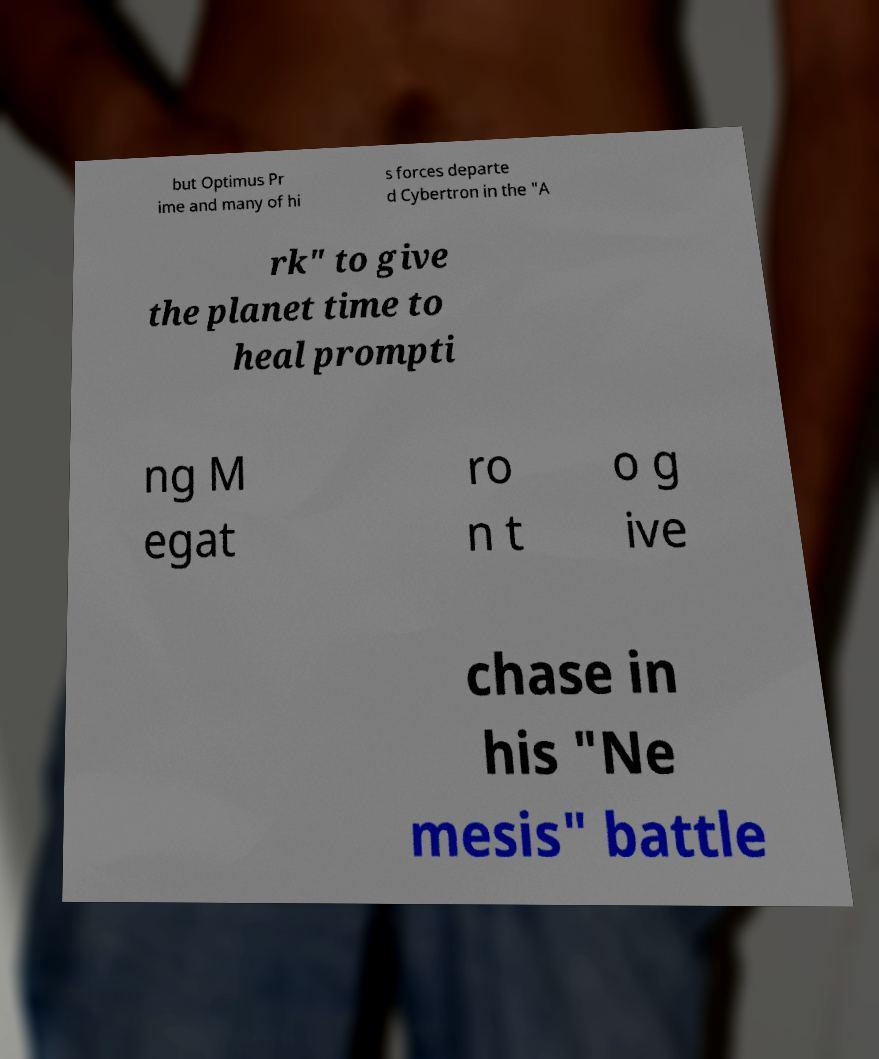Could you assist in decoding the text presented in this image and type it out clearly? but Optimus Pr ime and many of hi s forces departe d Cybertron in the "A rk" to give the planet time to heal prompti ng M egat ro n t o g ive chase in his "Ne mesis" battle 